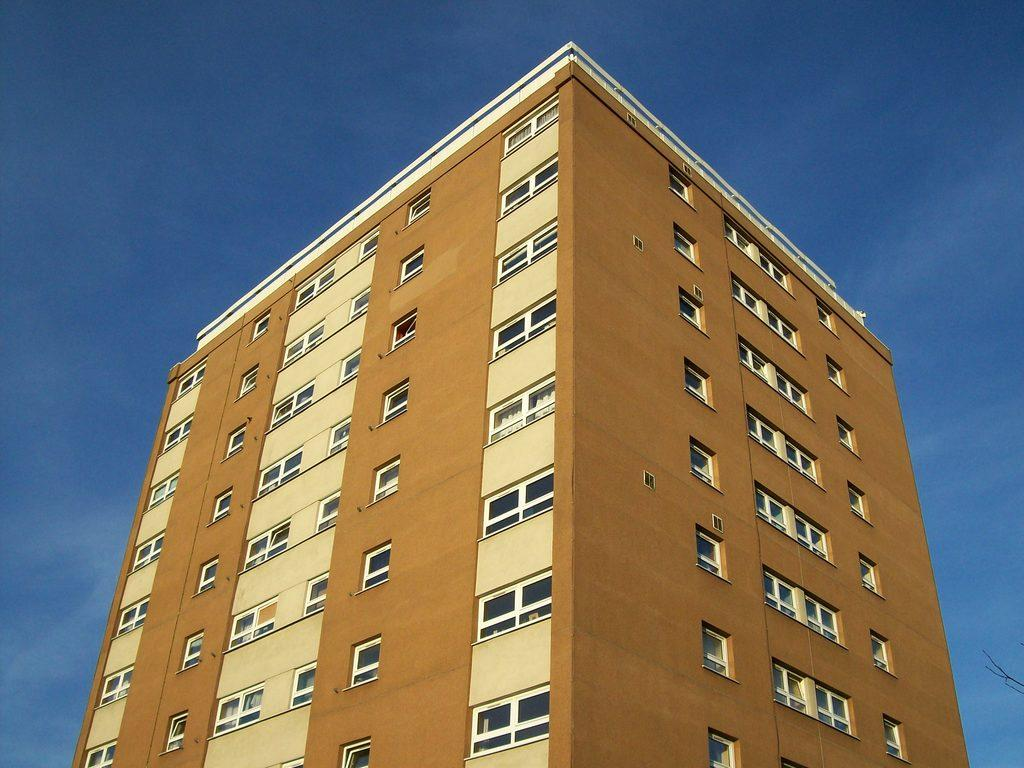What type of structure is present in the image? There is a building in the image. What is the condition of the sky in the image? The sky in the image is cloudy. How much money is being exchanged in the image? There is no indication of any money exchange in the image. What time of day is it in the image? The time of day cannot be determined from the image, as there is no specific information about the position of the sun or any other time-related indicators. 